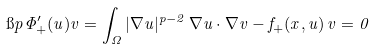Convert formula to latex. <formula><loc_0><loc_0><loc_500><loc_500>\i p { \Phi _ { + } ^ { \prime } ( u ) } { v } = \int _ { \Omega } | \nabla u | ^ { p - 2 } \, \nabla u \cdot \nabla v - f _ { + } ( x , u ) \, v = 0</formula> 